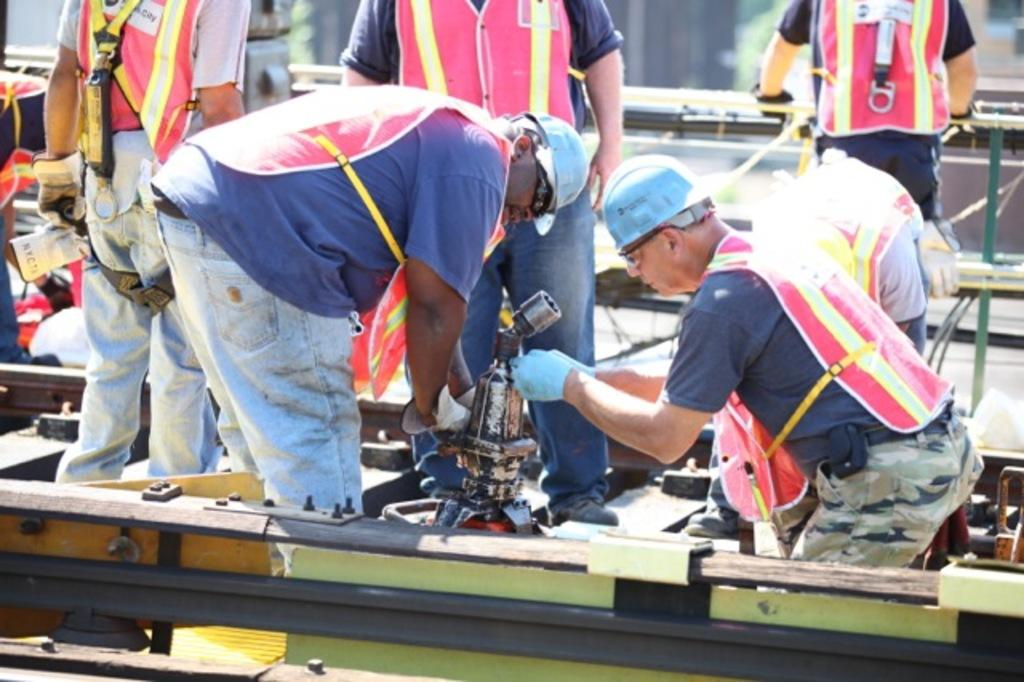What are the persons in the image doing on the railway track? The persons in the image are standing on the railway track and working. What are the persons wearing while working on the railway track? The persons are wearing safety jackets. What can be seen on the railway track besides the persons? There is a mechanical machine on the railway track. What type of waste can be seen on the railway track in the image? There is no waste visible in the image; the focus is on the persons working and the mechanical machine. Can you see any stars in the sky in the image? The image does not show the sky, so it is not possible to determine if any stars are visible. 